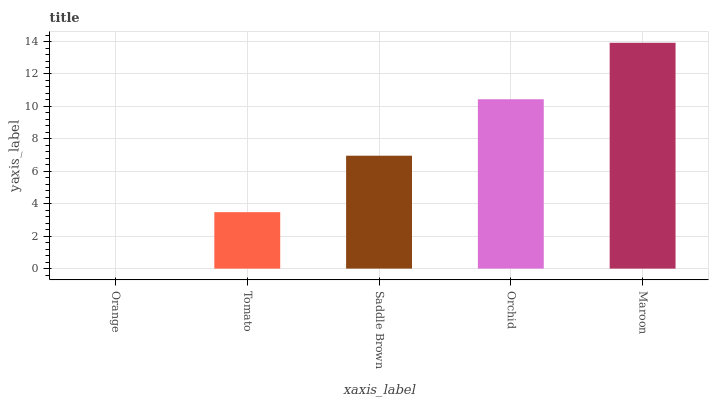Is Tomato the minimum?
Answer yes or no. No. Is Tomato the maximum?
Answer yes or no. No. Is Tomato greater than Orange?
Answer yes or no. Yes. Is Orange less than Tomato?
Answer yes or no. Yes. Is Orange greater than Tomato?
Answer yes or no. No. Is Tomato less than Orange?
Answer yes or no. No. Is Saddle Brown the high median?
Answer yes or no. Yes. Is Saddle Brown the low median?
Answer yes or no. Yes. Is Maroon the high median?
Answer yes or no. No. Is Orange the low median?
Answer yes or no. No. 